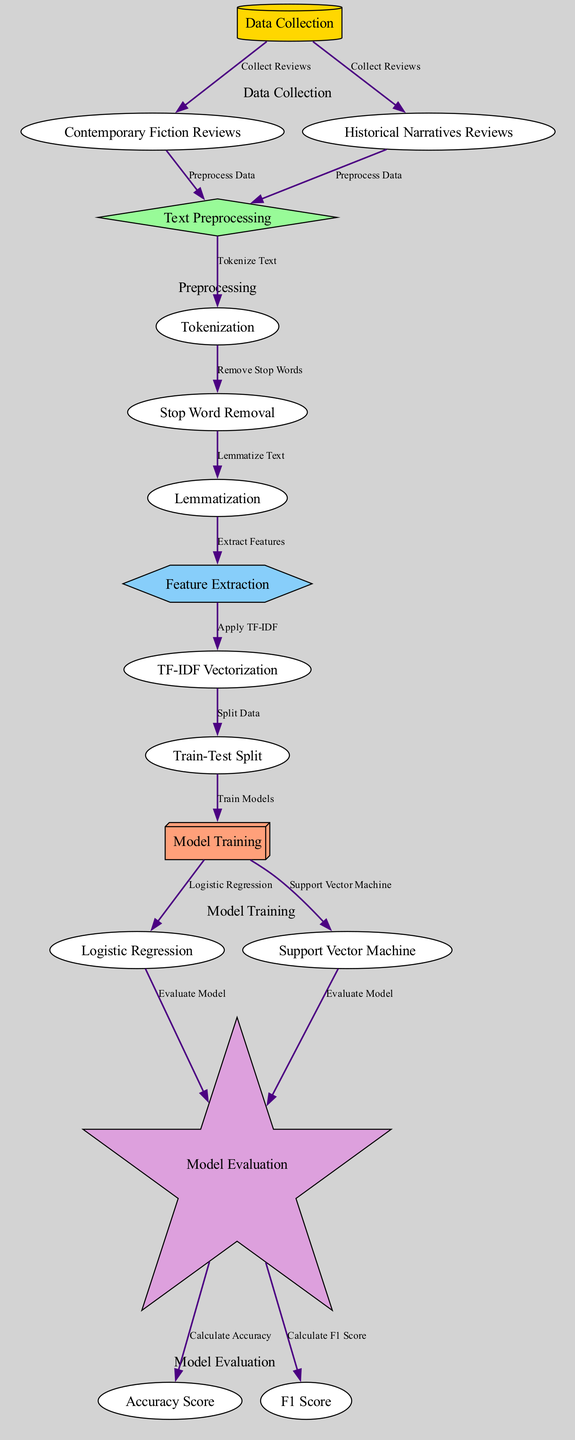What are the two main types of reviews collected in the data collection phase? In the diagram, the nodes connected to "Data Collection" are "Contemporary Fiction Reviews" and "Historical Narratives Reviews". These represent the two main types of reviews being analyzed.
Answer: Contemporary Fiction Reviews, Historical Narratives Reviews What pre-processing steps follow tokenization? The diagram shows that after "Tokenization", the next steps include "Stop Word Removal" and then "Lemmatization", forming a sequence of processes that prepare the text for analysis.
Answer: Stop Word Removal, Lemmatization How many models are being trained in the model training phase? The "Model Training" node connects to two different models: "Logistic Regression" and "Support Vector Machine". Therefore, there are two models being trained.
Answer: 2 What is the purpose of applying TF-IDF in the feature extraction phase? The diagram indicates that "Apply TF-IDF" is a processing step in "Feature Extraction" which transforms the tokenized text into numerical vectors, enabling the model to recognize and weigh the significance of terms relevant to sentiment.
Answer: To transform text into numerical vectors Which evaluation metrics are calculated after model evaluation? The diagram illustrates that after "Model Evaluation", two metrics are calculated: "Accuracy Score" and "F1 Score", which provide insights into the model's performance.
Answer: Accuracy Score, F1 Score Which process immediately follows the feature extraction stage? The diagram indicates that after "Feature Extraction", the next step is "TF-IDF Vectorization", which plays a crucial role in preparing the data for machine learning models.
Answer: TF-IDF Vectorization What is the color of the nodes representing the preprocessing steps in the diagram? In the diagram, the nodes related to "Preprocessing" are shaded in light green, distinguishing them from other steps in the process.
Answer: Light green What is the first step involved in preparing the reviews for sentiment analysis? According to the diagram, the first action in this workflow is "Data Collection", which involves gathering both contemporary fiction and historical narrative reviews for further analysis.
Answer: Data Collection 